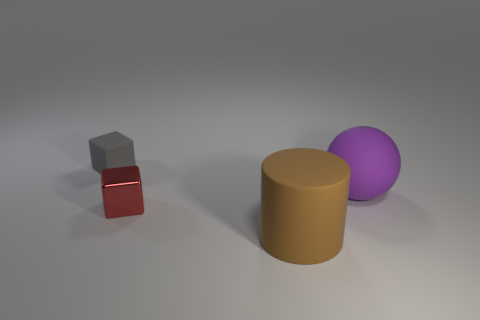Add 4 tiny red metal cylinders. How many objects exist? 8 Subtract all balls. How many objects are left? 3 Add 3 small red blocks. How many small red blocks are left? 4 Add 3 small green rubber objects. How many small green rubber objects exist? 3 Subtract 0 cyan cylinders. How many objects are left? 4 Subtract all large rubber objects. Subtract all purple shiny cylinders. How many objects are left? 2 